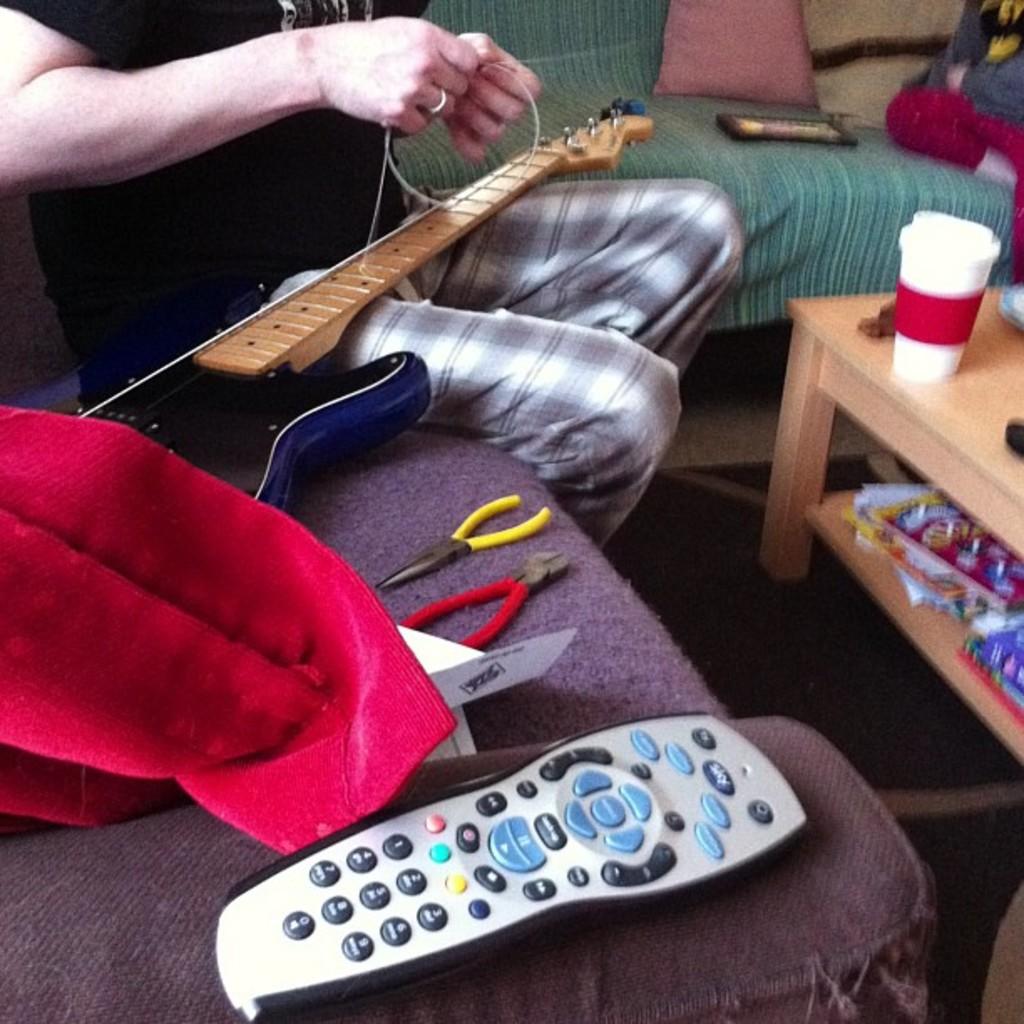What is the very bottom bottom on the remote control?
Give a very brief answer. 0. What digit is closest to the red button?
Your answer should be very brief. 1. 